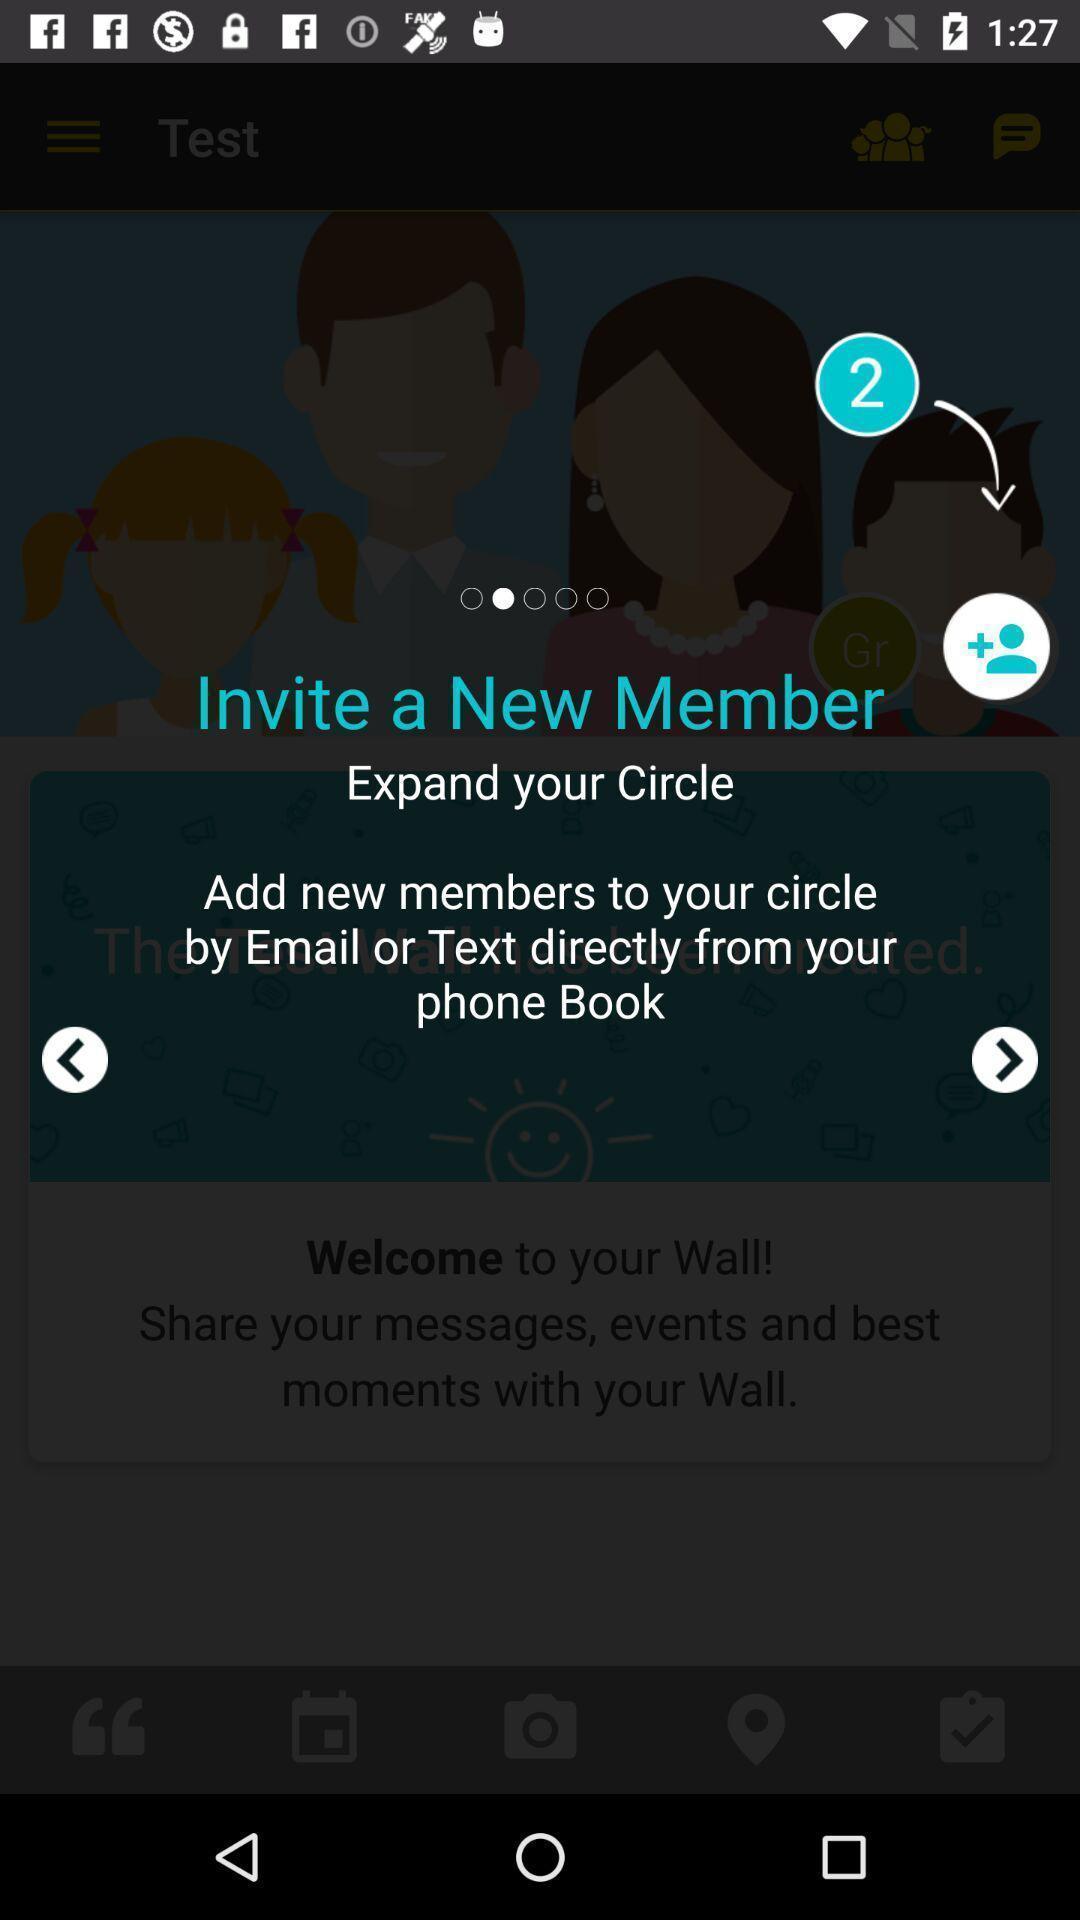What can you discern from this picture? Pop up displaying the invitation of new members. 